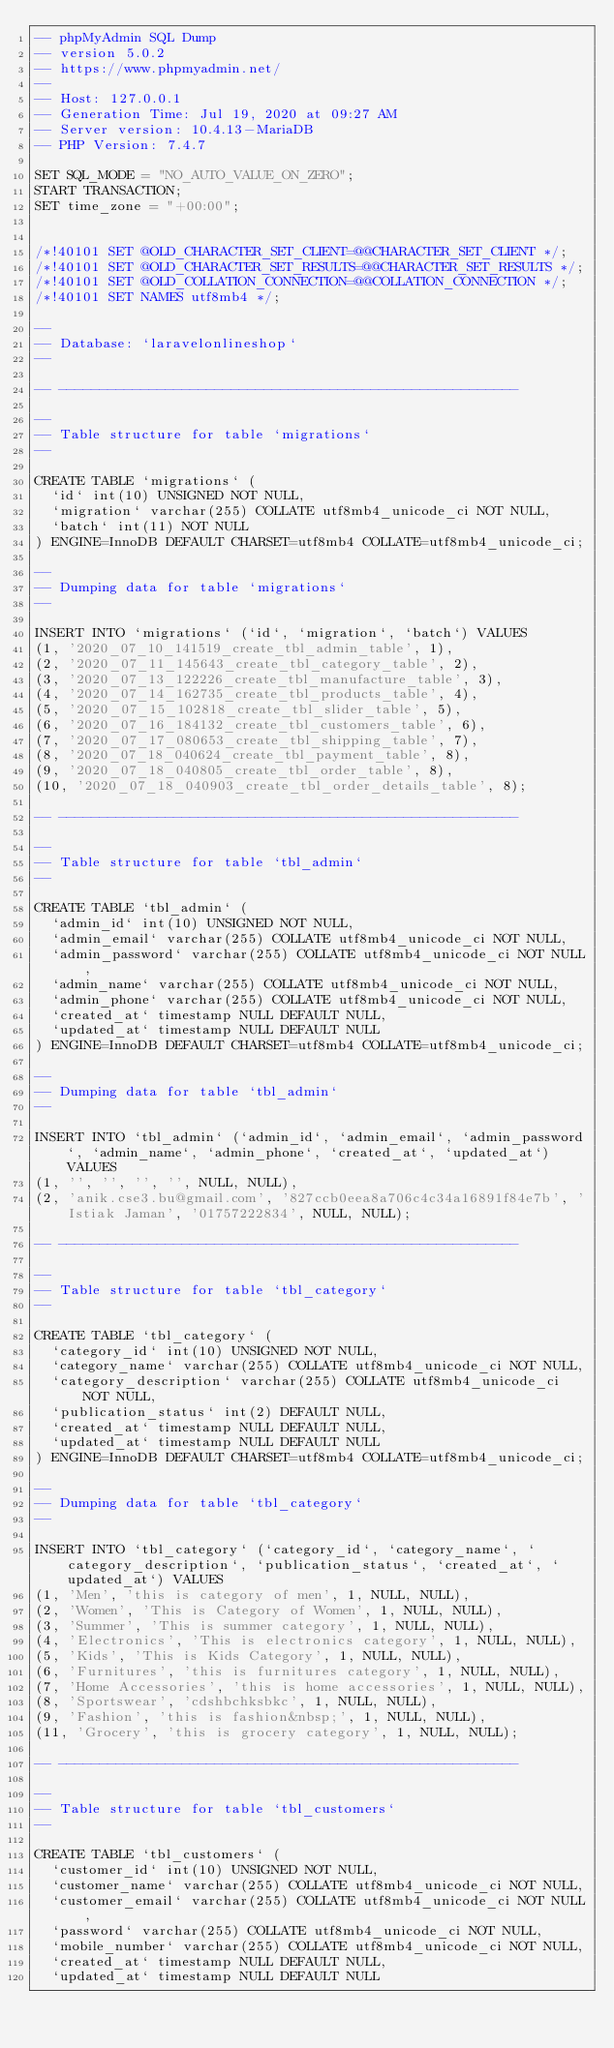Convert code to text. <code><loc_0><loc_0><loc_500><loc_500><_SQL_>-- phpMyAdmin SQL Dump
-- version 5.0.2
-- https://www.phpmyadmin.net/
--
-- Host: 127.0.0.1
-- Generation Time: Jul 19, 2020 at 09:27 AM
-- Server version: 10.4.13-MariaDB
-- PHP Version: 7.4.7

SET SQL_MODE = "NO_AUTO_VALUE_ON_ZERO";
START TRANSACTION;
SET time_zone = "+00:00";


/*!40101 SET @OLD_CHARACTER_SET_CLIENT=@@CHARACTER_SET_CLIENT */;
/*!40101 SET @OLD_CHARACTER_SET_RESULTS=@@CHARACTER_SET_RESULTS */;
/*!40101 SET @OLD_COLLATION_CONNECTION=@@COLLATION_CONNECTION */;
/*!40101 SET NAMES utf8mb4 */;

--
-- Database: `laravelonlineshop`
--

-- --------------------------------------------------------

--
-- Table structure for table `migrations`
--

CREATE TABLE `migrations` (
  `id` int(10) UNSIGNED NOT NULL,
  `migration` varchar(255) COLLATE utf8mb4_unicode_ci NOT NULL,
  `batch` int(11) NOT NULL
) ENGINE=InnoDB DEFAULT CHARSET=utf8mb4 COLLATE=utf8mb4_unicode_ci;

--
-- Dumping data for table `migrations`
--

INSERT INTO `migrations` (`id`, `migration`, `batch`) VALUES
(1, '2020_07_10_141519_create_tbl_admin_table', 1),
(2, '2020_07_11_145643_create_tbl_category_table', 2),
(3, '2020_07_13_122226_create_tbl_manufacture_table', 3),
(4, '2020_07_14_162735_create_tbl_products_table', 4),
(5, '2020_07_15_102818_create_tbl_slider_table', 5),
(6, '2020_07_16_184132_create_tbl_customers_table', 6),
(7, '2020_07_17_080653_create_tbl_shipping_table', 7),
(8, '2020_07_18_040624_create_tbl_payment_table', 8),
(9, '2020_07_18_040805_create_tbl_order_table', 8),
(10, '2020_07_18_040903_create_tbl_order_details_table', 8);

-- --------------------------------------------------------

--
-- Table structure for table `tbl_admin`
--

CREATE TABLE `tbl_admin` (
  `admin_id` int(10) UNSIGNED NOT NULL,
  `admin_email` varchar(255) COLLATE utf8mb4_unicode_ci NOT NULL,
  `admin_password` varchar(255) COLLATE utf8mb4_unicode_ci NOT NULL,
  `admin_name` varchar(255) COLLATE utf8mb4_unicode_ci NOT NULL,
  `admin_phone` varchar(255) COLLATE utf8mb4_unicode_ci NOT NULL,
  `created_at` timestamp NULL DEFAULT NULL,
  `updated_at` timestamp NULL DEFAULT NULL
) ENGINE=InnoDB DEFAULT CHARSET=utf8mb4 COLLATE=utf8mb4_unicode_ci;

--
-- Dumping data for table `tbl_admin`
--

INSERT INTO `tbl_admin` (`admin_id`, `admin_email`, `admin_password`, `admin_name`, `admin_phone`, `created_at`, `updated_at`) VALUES
(1, '', '', '', '', NULL, NULL),
(2, 'anik.cse3.bu@gmail.com', '827ccb0eea8a706c4c34a16891f84e7b', 'Istiak Jaman', '01757222834', NULL, NULL);

-- --------------------------------------------------------

--
-- Table structure for table `tbl_category`
--

CREATE TABLE `tbl_category` (
  `category_id` int(10) UNSIGNED NOT NULL,
  `category_name` varchar(255) COLLATE utf8mb4_unicode_ci NOT NULL,
  `category_description` varchar(255) COLLATE utf8mb4_unicode_ci NOT NULL,
  `publication_status` int(2) DEFAULT NULL,
  `created_at` timestamp NULL DEFAULT NULL,
  `updated_at` timestamp NULL DEFAULT NULL
) ENGINE=InnoDB DEFAULT CHARSET=utf8mb4 COLLATE=utf8mb4_unicode_ci;

--
-- Dumping data for table `tbl_category`
--

INSERT INTO `tbl_category` (`category_id`, `category_name`, `category_description`, `publication_status`, `created_at`, `updated_at`) VALUES
(1, 'Men', 'this is category of men', 1, NULL, NULL),
(2, 'Women', 'This is Category of Women', 1, NULL, NULL),
(3, 'Summer', 'This is summer category', 1, NULL, NULL),
(4, 'Electronics', 'This is electronics category', 1, NULL, NULL),
(5, 'Kids', 'This is Kids Category', 1, NULL, NULL),
(6, 'Furnitures', 'this is furnitures category', 1, NULL, NULL),
(7, 'Home Accessories', 'this is home accessories', 1, NULL, NULL),
(8, 'Sportswear', 'cdshbchksbkc', 1, NULL, NULL),
(9, 'Fashion', 'this is fashion&nbsp;', 1, NULL, NULL),
(11, 'Grocery', 'this is grocery category', 1, NULL, NULL);

-- --------------------------------------------------------

--
-- Table structure for table `tbl_customers`
--

CREATE TABLE `tbl_customers` (
  `customer_id` int(10) UNSIGNED NOT NULL,
  `customer_name` varchar(255) COLLATE utf8mb4_unicode_ci NOT NULL,
  `customer_email` varchar(255) COLLATE utf8mb4_unicode_ci NOT NULL,
  `password` varchar(255) COLLATE utf8mb4_unicode_ci NOT NULL,
  `mobile_number` varchar(255) COLLATE utf8mb4_unicode_ci NOT NULL,
  `created_at` timestamp NULL DEFAULT NULL,
  `updated_at` timestamp NULL DEFAULT NULL</code> 